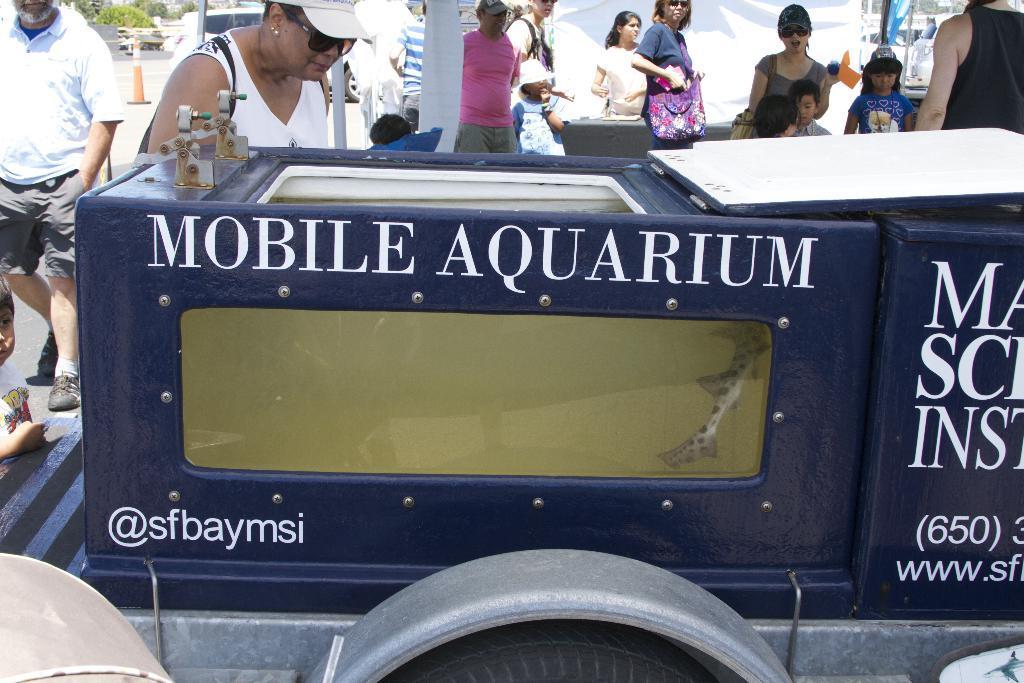Describe this image in one or two sentences. In this picture we can see a vehicle, aquarium and a group of people standing on the road and in the background we can see a traffic cone, trees. 